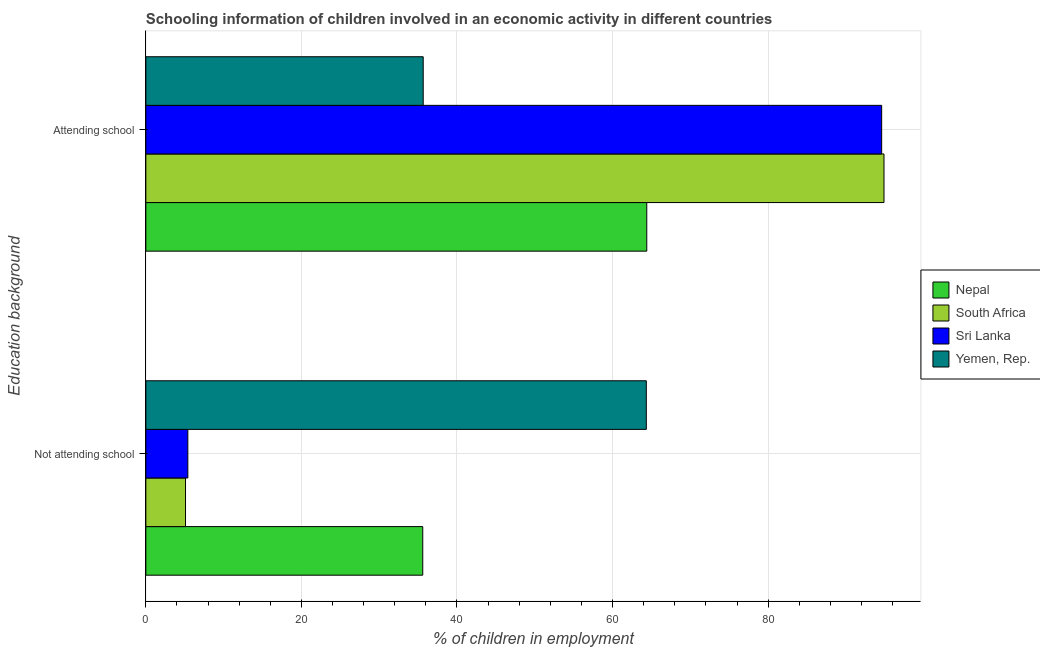How many different coloured bars are there?
Give a very brief answer. 4. How many groups of bars are there?
Ensure brevity in your answer.  2. Are the number of bars per tick equal to the number of legend labels?
Provide a short and direct response. Yes. Are the number of bars on each tick of the Y-axis equal?
Offer a very short reply. Yes. What is the label of the 1st group of bars from the top?
Make the answer very short. Attending school. What is the percentage of employed children who are attending school in South Africa?
Provide a succinct answer. 94.9. Across all countries, what is the maximum percentage of employed children who are not attending school?
Give a very brief answer. 64.34. Across all countries, what is the minimum percentage of employed children who are not attending school?
Your answer should be very brief. 5.1. In which country was the percentage of employed children who are not attending school maximum?
Make the answer very short. Yemen, Rep. In which country was the percentage of employed children who are attending school minimum?
Make the answer very short. Yemen, Rep. What is the total percentage of employed children who are not attending school in the graph?
Offer a terse response. 110.44. What is the difference between the percentage of employed children who are not attending school in Yemen, Rep. and that in Sri Lanka?
Provide a succinct answer. 58.94. What is the difference between the percentage of employed children who are attending school in South Africa and the percentage of employed children who are not attending school in Nepal?
Ensure brevity in your answer.  59.3. What is the average percentage of employed children who are not attending school per country?
Provide a short and direct response. 27.61. What is the difference between the percentage of employed children who are attending school and percentage of employed children who are not attending school in Sri Lanka?
Provide a succinct answer. 89.2. In how many countries, is the percentage of employed children who are not attending school greater than 68 %?
Provide a short and direct response. 0. What is the ratio of the percentage of employed children who are attending school in South Africa to that in Yemen, Rep.?
Your answer should be very brief. 2.66. What does the 4th bar from the top in Attending school represents?
Offer a very short reply. Nepal. What does the 3rd bar from the bottom in Not attending school represents?
Keep it short and to the point. Sri Lanka. How many bars are there?
Keep it short and to the point. 8. How many countries are there in the graph?
Give a very brief answer. 4. What is the difference between two consecutive major ticks on the X-axis?
Offer a terse response. 20. How are the legend labels stacked?
Offer a terse response. Vertical. What is the title of the graph?
Your response must be concise. Schooling information of children involved in an economic activity in different countries. What is the label or title of the X-axis?
Offer a very short reply. % of children in employment. What is the label or title of the Y-axis?
Keep it short and to the point. Education background. What is the % of children in employment in Nepal in Not attending school?
Give a very brief answer. 35.6. What is the % of children in employment in Sri Lanka in Not attending school?
Your response must be concise. 5.4. What is the % of children in employment in Yemen, Rep. in Not attending school?
Your answer should be compact. 64.34. What is the % of children in employment of Nepal in Attending school?
Your answer should be very brief. 64.4. What is the % of children in employment of South Africa in Attending school?
Provide a short and direct response. 94.9. What is the % of children in employment of Sri Lanka in Attending school?
Provide a short and direct response. 94.6. What is the % of children in employment in Yemen, Rep. in Attending school?
Keep it short and to the point. 35.66. Across all Education background, what is the maximum % of children in employment in Nepal?
Provide a short and direct response. 64.4. Across all Education background, what is the maximum % of children in employment in South Africa?
Your response must be concise. 94.9. Across all Education background, what is the maximum % of children in employment in Sri Lanka?
Offer a terse response. 94.6. Across all Education background, what is the maximum % of children in employment in Yemen, Rep.?
Keep it short and to the point. 64.34. Across all Education background, what is the minimum % of children in employment of Nepal?
Give a very brief answer. 35.6. Across all Education background, what is the minimum % of children in employment of South Africa?
Your answer should be very brief. 5.1. Across all Education background, what is the minimum % of children in employment in Sri Lanka?
Offer a terse response. 5.4. Across all Education background, what is the minimum % of children in employment of Yemen, Rep.?
Provide a succinct answer. 35.66. What is the total % of children in employment in South Africa in the graph?
Provide a succinct answer. 100. What is the total % of children in employment in Yemen, Rep. in the graph?
Offer a terse response. 100. What is the difference between the % of children in employment of Nepal in Not attending school and that in Attending school?
Provide a succinct answer. -28.8. What is the difference between the % of children in employment in South Africa in Not attending school and that in Attending school?
Offer a very short reply. -89.8. What is the difference between the % of children in employment in Sri Lanka in Not attending school and that in Attending school?
Give a very brief answer. -89.2. What is the difference between the % of children in employment in Yemen, Rep. in Not attending school and that in Attending school?
Offer a very short reply. 28.68. What is the difference between the % of children in employment of Nepal in Not attending school and the % of children in employment of South Africa in Attending school?
Provide a succinct answer. -59.3. What is the difference between the % of children in employment in Nepal in Not attending school and the % of children in employment in Sri Lanka in Attending school?
Your answer should be compact. -59. What is the difference between the % of children in employment of Nepal in Not attending school and the % of children in employment of Yemen, Rep. in Attending school?
Your answer should be very brief. -0.06. What is the difference between the % of children in employment in South Africa in Not attending school and the % of children in employment in Sri Lanka in Attending school?
Provide a succinct answer. -89.5. What is the difference between the % of children in employment of South Africa in Not attending school and the % of children in employment of Yemen, Rep. in Attending school?
Make the answer very short. -30.56. What is the difference between the % of children in employment in Sri Lanka in Not attending school and the % of children in employment in Yemen, Rep. in Attending school?
Ensure brevity in your answer.  -30.26. What is the average % of children in employment in Nepal per Education background?
Offer a very short reply. 50. What is the average % of children in employment in South Africa per Education background?
Offer a terse response. 50. What is the average % of children in employment in Yemen, Rep. per Education background?
Provide a succinct answer. 50. What is the difference between the % of children in employment of Nepal and % of children in employment of South Africa in Not attending school?
Your answer should be compact. 30.5. What is the difference between the % of children in employment of Nepal and % of children in employment of Sri Lanka in Not attending school?
Ensure brevity in your answer.  30.2. What is the difference between the % of children in employment in Nepal and % of children in employment in Yemen, Rep. in Not attending school?
Offer a very short reply. -28.74. What is the difference between the % of children in employment of South Africa and % of children in employment of Yemen, Rep. in Not attending school?
Offer a terse response. -59.24. What is the difference between the % of children in employment in Sri Lanka and % of children in employment in Yemen, Rep. in Not attending school?
Offer a terse response. -58.94. What is the difference between the % of children in employment in Nepal and % of children in employment in South Africa in Attending school?
Offer a very short reply. -30.5. What is the difference between the % of children in employment in Nepal and % of children in employment in Sri Lanka in Attending school?
Offer a very short reply. -30.2. What is the difference between the % of children in employment of Nepal and % of children in employment of Yemen, Rep. in Attending school?
Offer a very short reply. 28.74. What is the difference between the % of children in employment in South Africa and % of children in employment in Sri Lanka in Attending school?
Your response must be concise. 0.3. What is the difference between the % of children in employment in South Africa and % of children in employment in Yemen, Rep. in Attending school?
Provide a short and direct response. 59.24. What is the difference between the % of children in employment in Sri Lanka and % of children in employment in Yemen, Rep. in Attending school?
Provide a short and direct response. 58.94. What is the ratio of the % of children in employment in Nepal in Not attending school to that in Attending school?
Ensure brevity in your answer.  0.55. What is the ratio of the % of children in employment of South Africa in Not attending school to that in Attending school?
Give a very brief answer. 0.05. What is the ratio of the % of children in employment in Sri Lanka in Not attending school to that in Attending school?
Ensure brevity in your answer.  0.06. What is the ratio of the % of children in employment of Yemen, Rep. in Not attending school to that in Attending school?
Your answer should be very brief. 1.8. What is the difference between the highest and the second highest % of children in employment of Nepal?
Give a very brief answer. 28.8. What is the difference between the highest and the second highest % of children in employment of South Africa?
Provide a short and direct response. 89.8. What is the difference between the highest and the second highest % of children in employment of Sri Lanka?
Provide a succinct answer. 89.2. What is the difference between the highest and the second highest % of children in employment in Yemen, Rep.?
Your response must be concise. 28.68. What is the difference between the highest and the lowest % of children in employment of Nepal?
Give a very brief answer. 28.8. What is the difference between the highest and the lowest % of children in employment of South Africa?
Ensure brevity in your answer.  89.8. What is the difference between the highest and the lowest % of children in employment in Sri Lanka?
Offer a very short reply. 89.2. What is the difference between the highest and the lowest % of children in employment in Yemen, Rep.?
Your answer should be very brief. 28.68. 